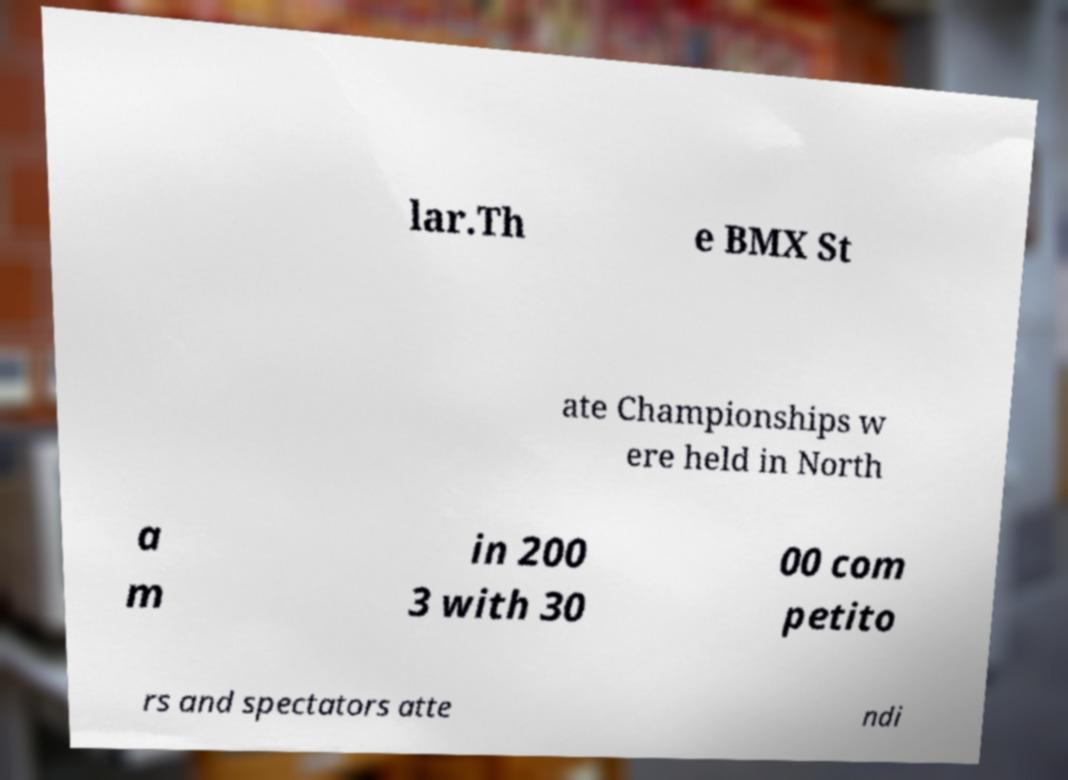Can you read and provide the text displayed in the image?This photo seems to have some interesting text. Can you extract and type it out for me? lar.Th e BMX St ate Championships w ere held in North a m in 200 3 with 30 00 com petito rs and spectators atte ndi 